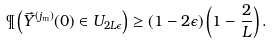Convert formula to latex. <formula><loc_0><loc_0><loc_500><loc_500>\P \left ( \vec { Y } ^ { ( j _ { m } ) } ( 0 ) \in U _ { 2 L \epsilon } \right ) \geq ( 1 - 2 \epsilon ) \left ( 1 - \frac { 2 } { L } \right ) .</formula> 